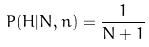Convert formula to latex. <formula><loc_0><loc_0><loc_500><loc_500>P ( H | N , n ) = \frac { 1 } { N + 1 }</formula> 